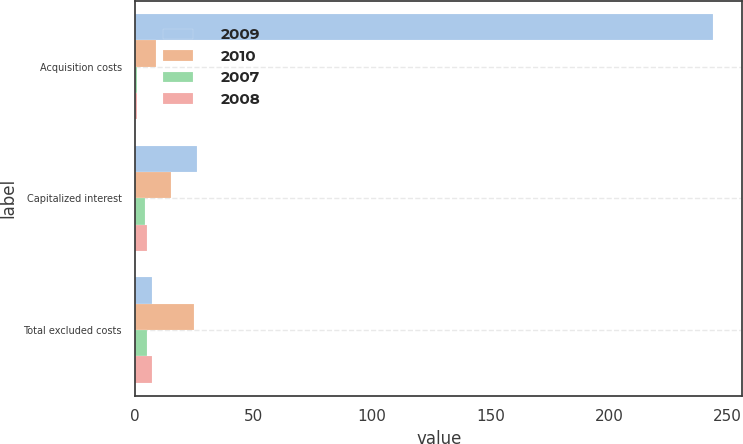Convert chart. <chart><loc_0><loc_0><loc_500><loc_500><stacked_bar_chart><ecel><fcel>Acquisition costs<fcel>Capitalized interest<fcel>Total excluded costs<nl><fcel>2009<fcel>244<fcel>26<fcel>7<nl><fcel>2010<fcel>9<fcel>15<fcel>25<nl><fcel>2007<fcel>1<fcel>4<fcel>5<nl><fcel>2008<fcel>1<fcel>5<fcel>7<nl></chart> 